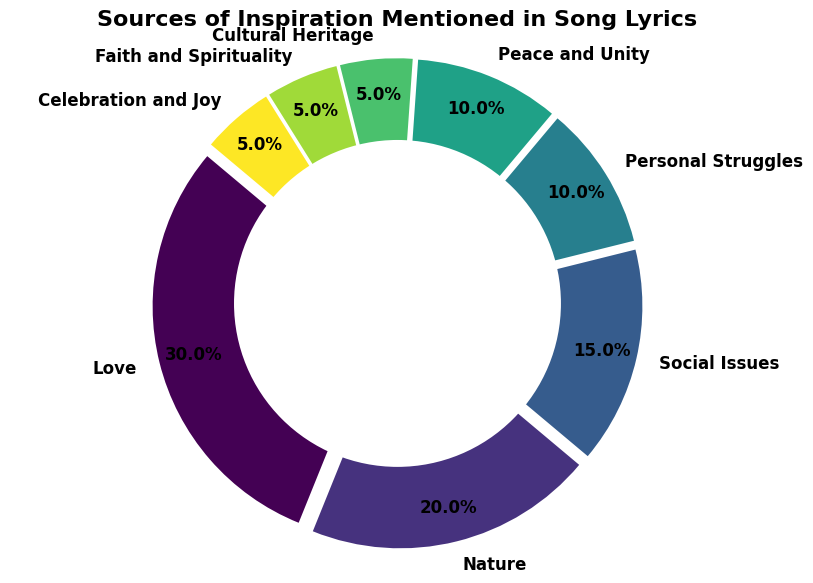What's the most common source of inspiration mentioned in song lyrics? The slice with the largest percentage represents the most common source. In this chart, the largest slice corresponds to "Love," which accounts for 30%.
Answer: Love Which sources of inspiration together make up at least 50% of the total mentioned in song lyrics? To find the sources that together make up at least 50%, sum the percentages in descending order: Love (30%) + Nature (20%) = 50%.
Answer: Love and Nature What percentage of sources of inspiration are related to 'Faith and Spirituality' and 'Cultural Heritage' combined? Add the percentage of 'Faith and Spirituality' (5%) and 'Cultural Heritage' (5%): 5% + 5% = 10%.
Answer: 10% Is the percentage of songs inspired by Social Issues greater than the percentage inspired by Personal Struggles? Compare the percentages for 'Social Issues' (15%) and 'Personal Struggles' (10%). Since 15% is greater than 10%, the percentage for 'Social Issues' is indeed greater.
Answer: Yes Which source of inspiration has the same percentage as 'Celebration and Joy'? 'Celebration and Joy' has a percentage of 5%. The other source with 5% is 'Faith and Spirituality' and 'Cultural Heritage'.
Answer: Faith and Spirituality and Cultural Heritage How much larger is the 'Nature' slice compared to the 'Peace and Unity' slice? Subtract the percentage of 'Peace and Unity' (10%) from 'Nature' (20%): 20% - 10% = 10%.
Answer: 10% Is 'Nature' one of the top three most mentioned sources of inspiration? The top three slices by percentage are 'Love' (30%), 'Nature' (20%), and 'Social Issues' (15%). Since 'Nature' is listed here, it is indeed one of the top three.
Answer: Yes What is the total percentage for sources related to positive themes such as 'Peace and Unity,' 'Faith and Spirituality,' and 'Celebration and Joy'? Add the percentages for these sources: 'Peace and Unity' (10%) + 'Faith and Spirituality' (5%) + 'Celebration and Joy' (5%) = 20%.
Answer: 20% Which source has a visually distinct color that stands out the most? Visually, the slice corresponding to 'Love' might stand out due to its larger size and possibly distinct color, depending on the colormap used. As we highlighted the largest slice, we assume 'Love' is the most noticeable.
Answer: Love 